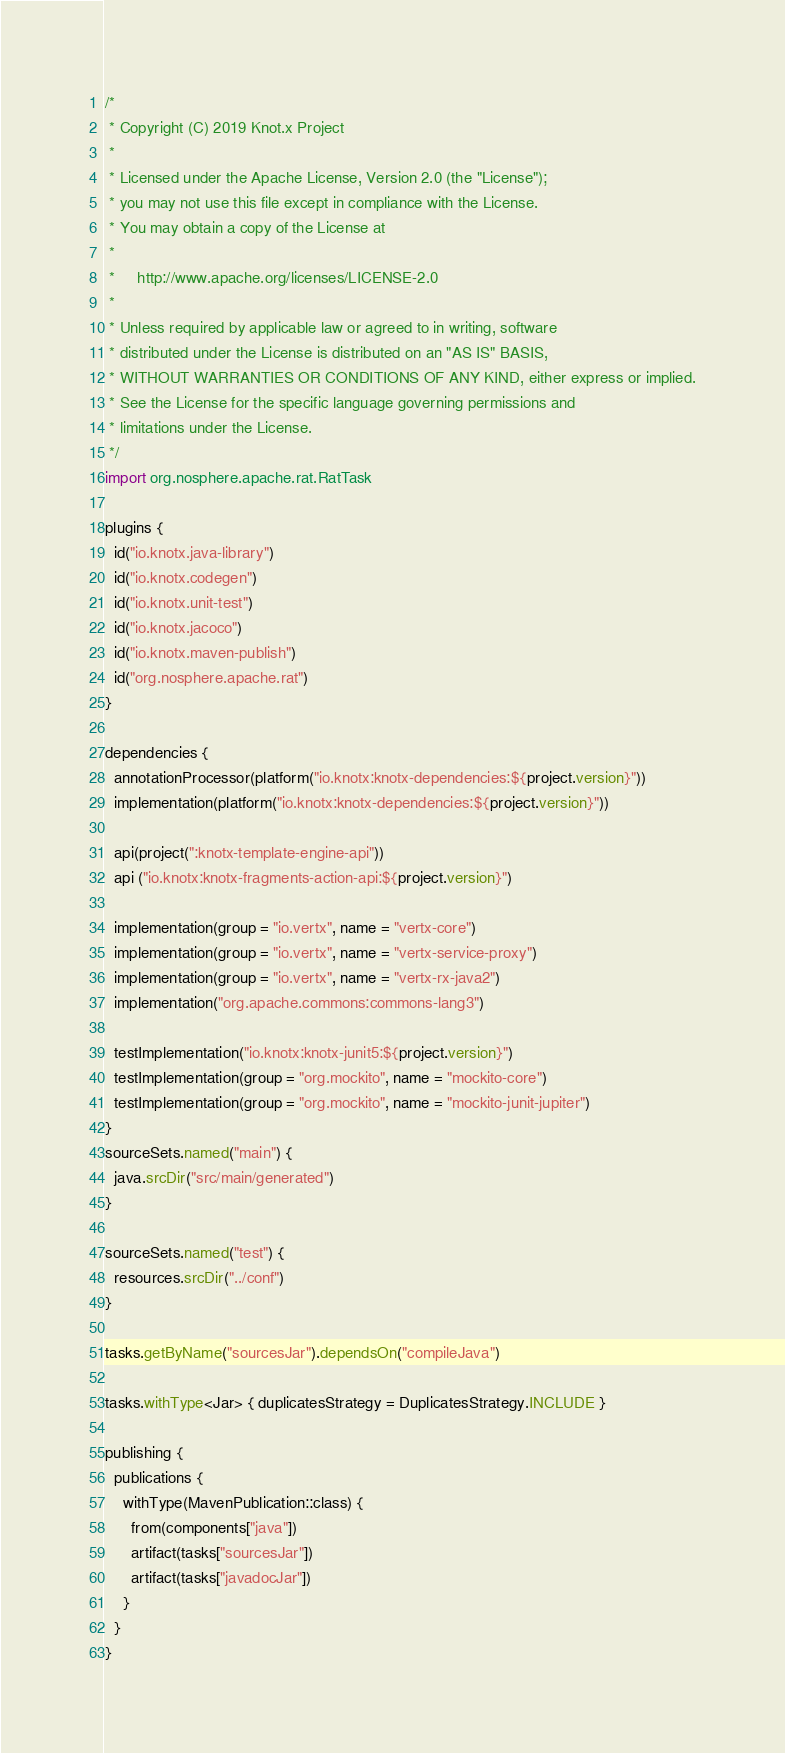Convert code to text. <code><loc_0><loc_0><loc_500><loc_500><_Kotlin_>/*
 * Copyright (C) 2019 Knot.x Project
 *
 * Licensed under the Apache License, Version 2.0 (the "License");
 * you may not use this file except in compliance with the License.
 * You may obtain a copy of the License at
 *
 *     http://www.apache.org/licenses/LICENSE-2.0
 *
 * Unless required by applicable law or agreed to in writing, software
 * distributed under the License is distributed on an "AS IS" BASIS,
 * WITHOUT WARRANTIES OR CONDITIONS OF ANY KIND, either express or implied.
 * See the License for the specific language governing permissions and
 * limitations under the License.
 */
import org.nosphere.apache.rat.RatTask

plugins {
  id("io.knotx.java-library")
  id("io.knotx.codegen")
  id("io.knotx.unit-test")
  id("io.knotx.jacoco")
  id("io.knotx.maven-publish")
  id("org.nosphere.apache.rat")
}

dependencies {
  annotationProcessor(platform("io.knotx:knotx-dependencies:${project.version}"))
  implementation(platform("io.knotx:knotx-dependencies:${project.version}"))

  api(project(":knotx-template-engine-api"))
  api ("io.knotx:knotx-fragments-action-api:${project.version}")

  implementation(group = "io.vertx", name = "vertx-core")
  implementation(group = "io.vertx", name = "vertx-service-proxy")
  implementation(group = "io.vertx", name = "vertx-rx-java2")
  implementation("org.apache.commons:commons-lang3")

  testImplementation("io.knotx:knotx-junit5:${project.version}")
  testImplementation(group = "org.mockito", name = "mockito-core")
  testImplementation(group = "org.mockito", name = "mockito-junit-jupiter")
}
sourceSets.named("main") {
  java.srcDir("src/main/generated")
}

sourceSets.named("test") {
  resources.srcDir("../conf")
}

tasks.getByName("sourcesJar").dependsOn("compileJava")

tasks.withType<Jar> { duplicatesStrategy = DuplicatesStrategy.INCLUDE }

publishing {
  publications {
    withType(MavenPublication::class) {
      from(components["java"])
      artifact(tasks["sourcesJar"])
      artifact(tasks["javadocJar"])
    }
  }
}</code> 